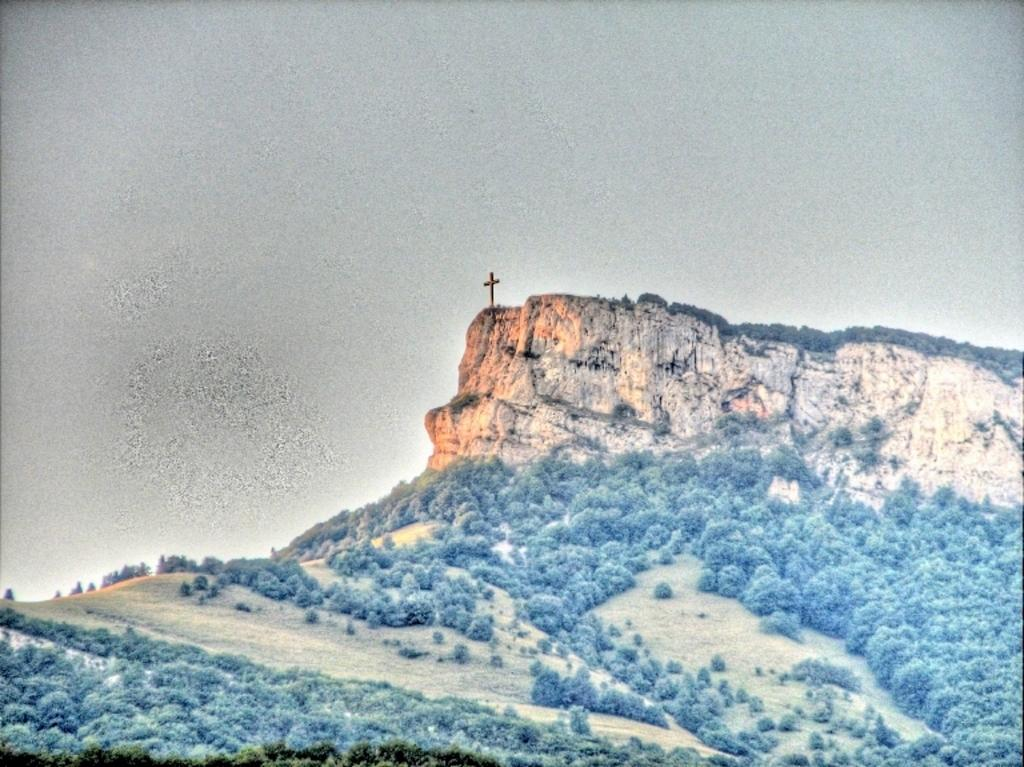What type of living organisms can be seen in the image? Plants can be seen in the image. What geographical features are present in the image? There are hills in the image. What is the condition of the sky in the image? The sky is cloudy in the image. Can you see a kite flying in the image? There is no kite visible in the image. Is there a bone present in the image? There is no bone present in the image. 